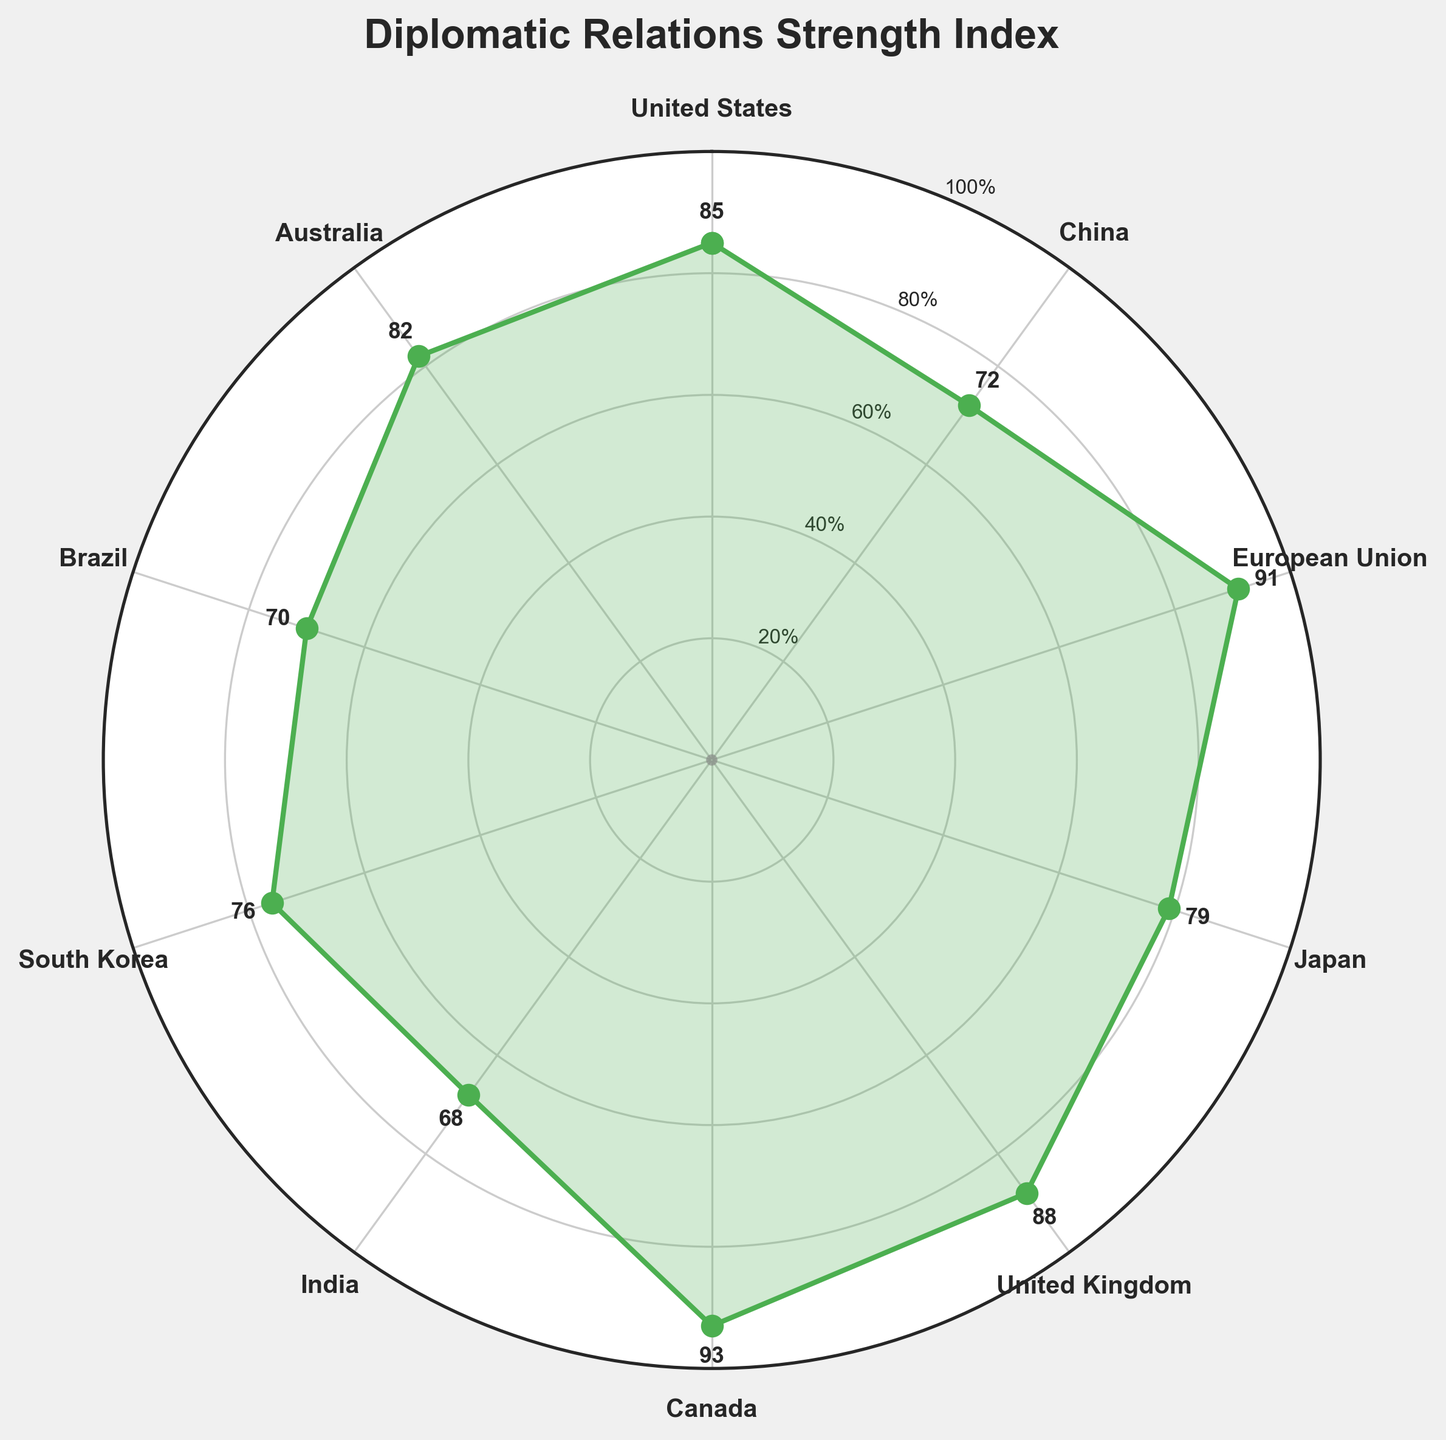What's the title of the figure? The title of the figure is displayed prominently at the top and reads "Diplomatic Relations Strength Index".
Answer: Diplomatic Relations Strength Index How many countries are represented in the figure? To find the number of countries, look at the number of data points or the labels around the figure. There are ten countries listed.
Answer: 10 Which country has the highest Diplomatic Relations Strength Index? The value of the Diplomatic Relations Strength Index is marked beside each country's label. The highest index is 93, corresponding to Canada.
Answer: Canada Which country has the lowest Diplomatic Relations Strength Index? The value of the Diplomatic Relations Strength Index is marked beside each country's label. The lowest index is 68, corresponding to India.
Answer: India What is the average Diplomatic Relations Strength Index across all countries? Sum up all the Diplomatic Relations Strength Index values and divide by the number of countries: (85 + 72 + 91 + 79 + 88 + 93 + 68 + 76 + 70 + 82) / 10 = 80.4.
Answer: 80.4 Which countries have a Diplomatic Relations Strength Index greater than 80? By checking the values beside each country's label, we see that the United States (85), European Union (91), United Kingdom (88), Canada (93), and Australia (82) all have indices greater than 80.
Answer: United States, European Union, United Kingdom, Canada, Australia What is the range of the Diplomatic Relations Strength Index values? The range is calculated by subtracting the lowest value from the highest value: 93 (Canada) - 68 (India) = 25.
Answer: 25 How many countries have a Diplomatic Relations Strength Index below 75? By checking the values, we see that China (72), India (68), South Korea (76), and Brazil (70) have indices below 75.
Answer: 4 Which country has a Diplomatic Relations Strength Index closest to 80? The countries around 80 are Japan (79) and Australia (82). The closest to 80 is Japan, which has an index of 79.
Answer: Japan 